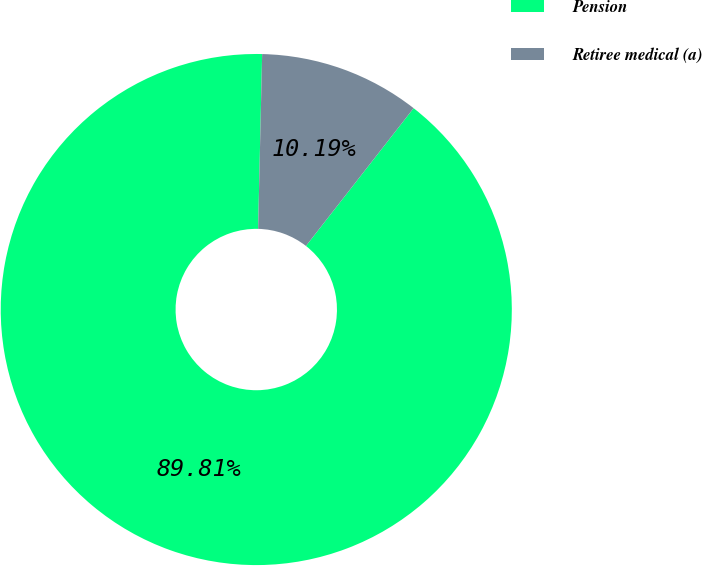Convert chart. <chart><loc_0><loc_0><loc_500><loc_500><pie_chart><fcel>Pension<fcel>Retiree medical (a)<nl><fcel>89.81%<fcel>10.19%<nl></chart> 